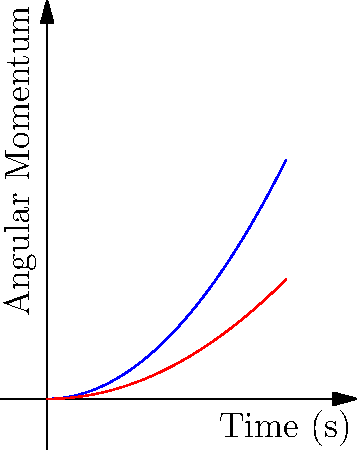Based on the graph showing the angular momentum over time for a discus throw and a hammer throw, which implement typically exhibits a higher angular momentum during the throwing motion, and why might this be the case? Let's analyze this step-by-step:

1. The graph shows the angular momentum over time for both a discus throw and a hammer throw.

2. The blue curve represents the discus, while the red curve represents the hammer.

3. We can see that the blue curve (discus) rises more steeply and reaches a higher point on the y-axis compared to the red curve (hammer).

4. This indicates that the discus typically achieves a higher angular momentum during the throwing motion.

5. The reason for this difference lies in the mechanics of the throws:
   a) A discus is thrown with a spinning motion, where the athlete rotates their entire body multiple times before release.
   b) The hammer, while also involving rotation, is swung in a circular motion with the athlete typically making fewer full body rotations.

6. The discus throw allows for a greater build-up of angular momentum due to:
   a) The wider radius of rotation (the outstretched arm holding the discus).
   b) The multiple full-body rotations performed by the athlete.

7. In contrast, the hammer's angular momentum is somewhat limited by:
   a) The shorter radius of rotation (the length of the wire).
   b) Fewer full-body rotations by the athlete.

8. It's important to note that while the discus typically achieves higher angular momentum, the hammer can still be thrown further due to other factors like the implement's mass and the wire providing additional leverage.
Answer: Discus typically exhibits higher angular momentum due to wider rotation radius and more full-body rotations. 